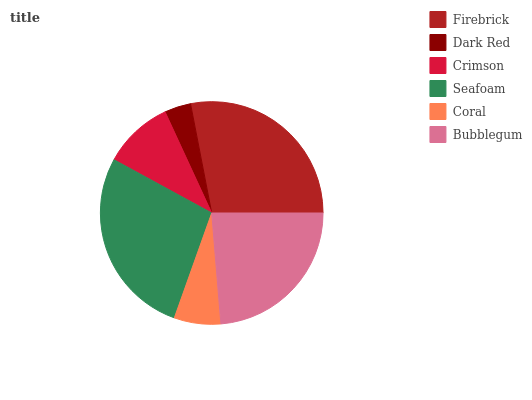Is Dark Red the minimum?
Answer yes or no. Yes. Is Firebrick the maximum?
Answer yes or no. Yes. Is Crimson the minimum?
Answer yes or no. No. Is Crimson the maximum?
Answer yes or no. No. Is Crimson greater than Dark Red?
Answer yes or no. Yes. Is Dark Red less than Crimson?
Answer yes or no. Yes. Is Dark Red greater than Crimson?
Answer yes or no. No. Is Crimson less than Dark Red?
Answer yes or no. No. Is Bubblegum the high median?
Answer yes or no. Yes. Is Crimson the low median?
Answer yes or no. Yes. Is Firebrick the high median?
Answer yes or no. No. Is Bubblegum the low median?
Answer yes or no. No. 